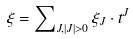<formula> <loc_0><loc_0><loc_500><loc_500>\xi = \sum \nolimits _ { J , \left | J \right | > 0 } \xi _ { J } \cdot t ^ { J }</formula> 